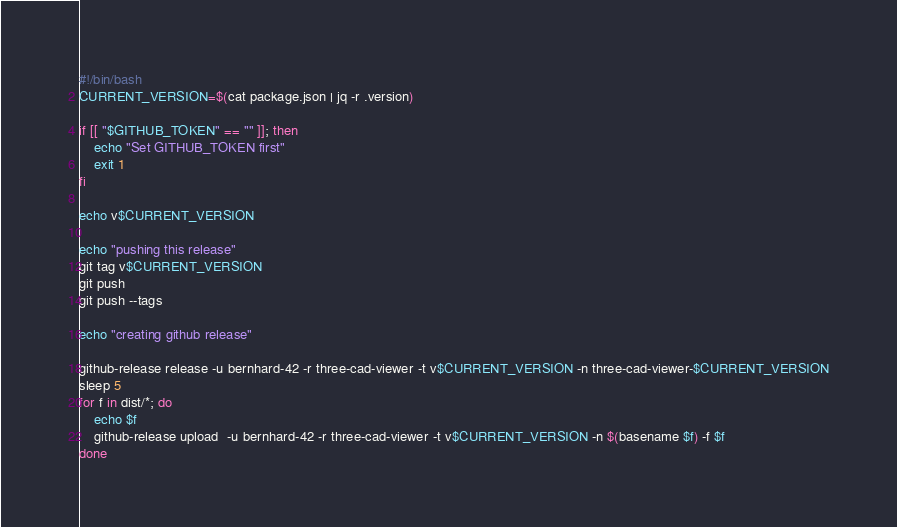Convert code to text. <code><loc_0><loc_0><loc_500><loc_500><_Bash_>#!/bin/bash
CURRENT_VERSION=$(cat package.json | jq -r .version)

if [[ "$GITHUB_TOKEN" == "" ]]; then
    echo "Set GITHUB_TOKEN first"
    exit 1
fi

echo v$CURRENT_VERSION

echo "pushing this release"
git tag v$CURRENT_VERSION
git push
git push --tags

echo "creating github release"

github-release release -u bernhard-42 -r three-cad-viewer -t v$CURRENT_VERSION -n three-cad-viewer-$CURRENT_VERSION
sleep 5
for f in dist/*; do
    echo $f
    github-release upload  -u bernhard-42 -r three-cad-viewer -t v$CURRENT_VERSION -n $(basename $f) -f $f
done
</code> 